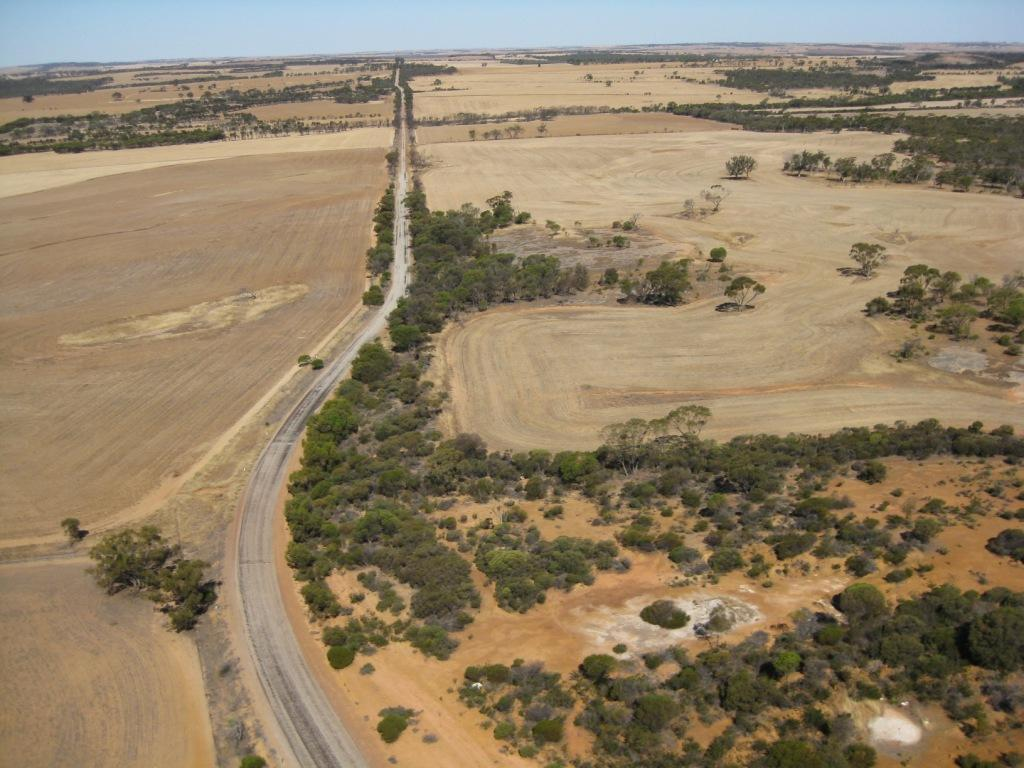What is the main feature of the image? There is a road in the image. What else can be seen in the image besides the road? There are trees in the image. What is visible in the background of the image? The sky is visible in the background of the image. What type of rhythm can be heard coming from the trees in the image? There is no sound or rhythm present in the image; it is a still image of a road and trees. 